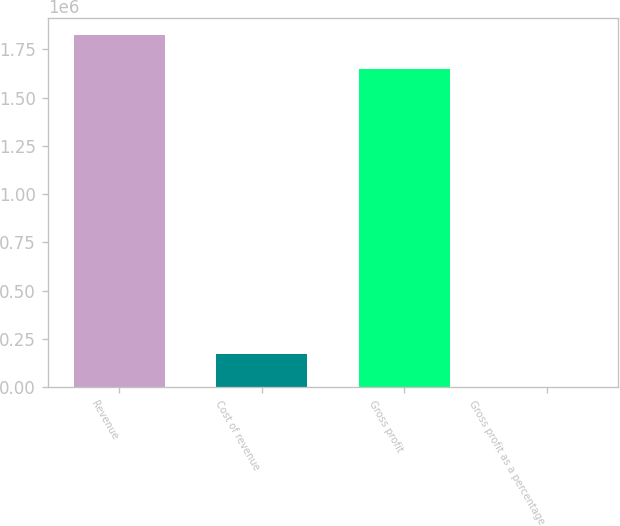<chart> <loc_0><loc_0><loc_500><loc_500><bar_chart><fcel>Revenue<fcel>Cost of revenue<fcel>Gross profit<fcel>Gross profit as a percentage<nl><fcel>1.82113e+06<fcel>171406<fcel>1.64982e+06<fcel>96<nl></chart> 